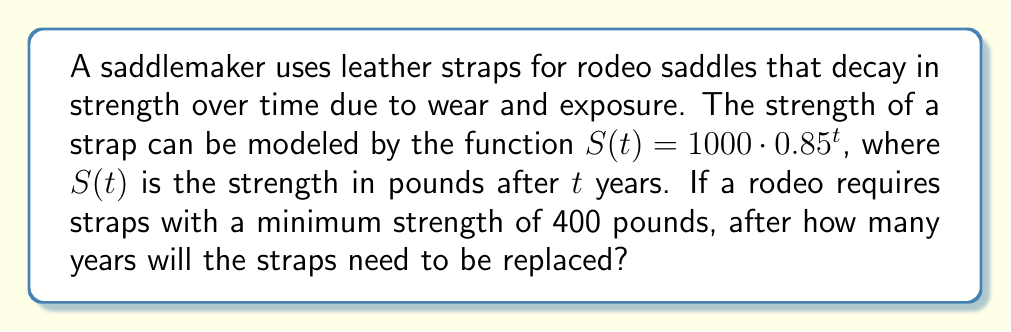Help me with this question. To solve this problem, we need to find the value of $t$ when $S(t) = 400$. Let's approach this step-by-step:

1) We start with the equation: $S(t) = 1000 \cdot 0.85^t$

2) We want to find $t$ when $S(t) = 400$, so we set up the equation:
   $400 = 1000 \cdot 0.85^t$

3) Divide both sides by 1000:
   $\frac{400}{1000} = 0.85^t$

4) Simplify:
   $0.4 = 0.85^t$

5) To solve for $t$, we need to take the logarithm of both sides. We can use any base, but the natural log (ln) is often convenient:
   $\ln(0.4) = \ln(0.85^t)$

6) Using the logarithm property $\ln(a^b) = b\ln(a)$:
   $\ln(0.4) = t \cdot \ln(0.85)$

7) Now we can solve for $t$:
   $t = \frac{\ln(0.4)}{\ln(0.85)}$

8) Using a calculator:
   $t \approx 5.7898$ years

9) Since we can't replace part of a strap, we need to round down to the nearest whole year. The straps will need to be replaced after 5 years.
Answer: 5 years 